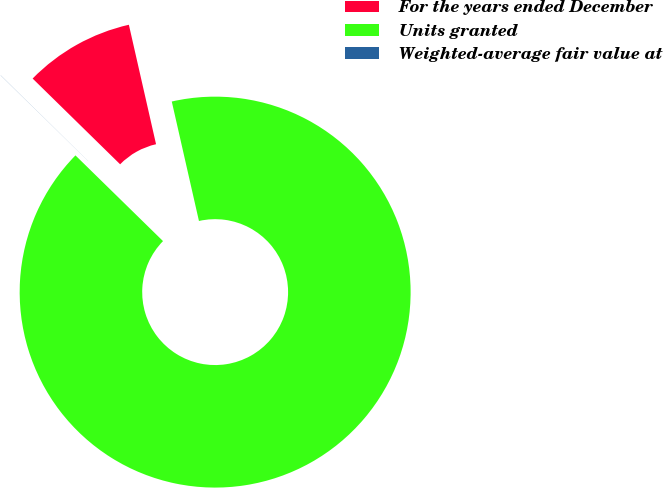Convert chart. <chart><loc_0><loc_0><loc_500><loc_500><pie_chart><fcel>For the years ended December<fcel>Units granted<fcel>Weighted-average fair value at<nl><fcel>9.1%<fcel>90.89%<fcel>0.01%<nl></chart> 